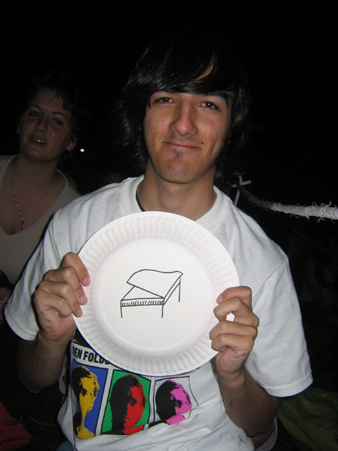<image>
Is there a dimples on the man? Yes. Looking at the image, I can see the dimples is positioned on top of the man, with the man providing support. 